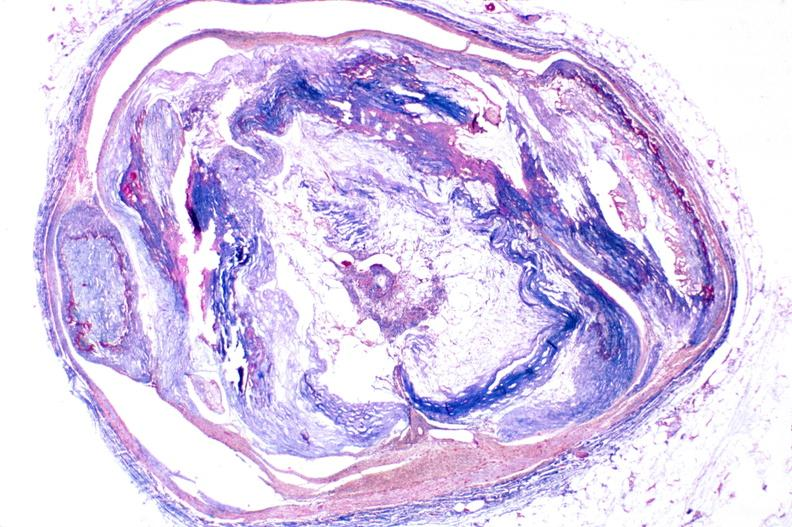what is present?
Answer the question using a single word or phrase. Vasculature 